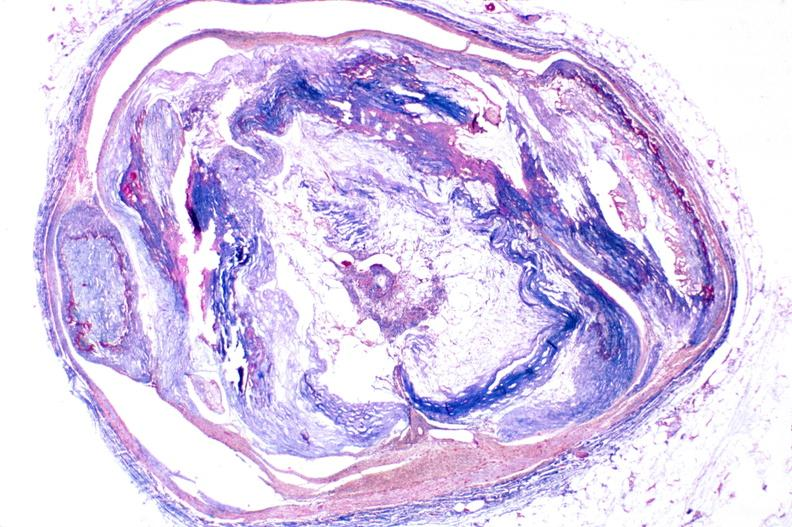what is present?
Answer the question using a single word or phrase. Vasculature 